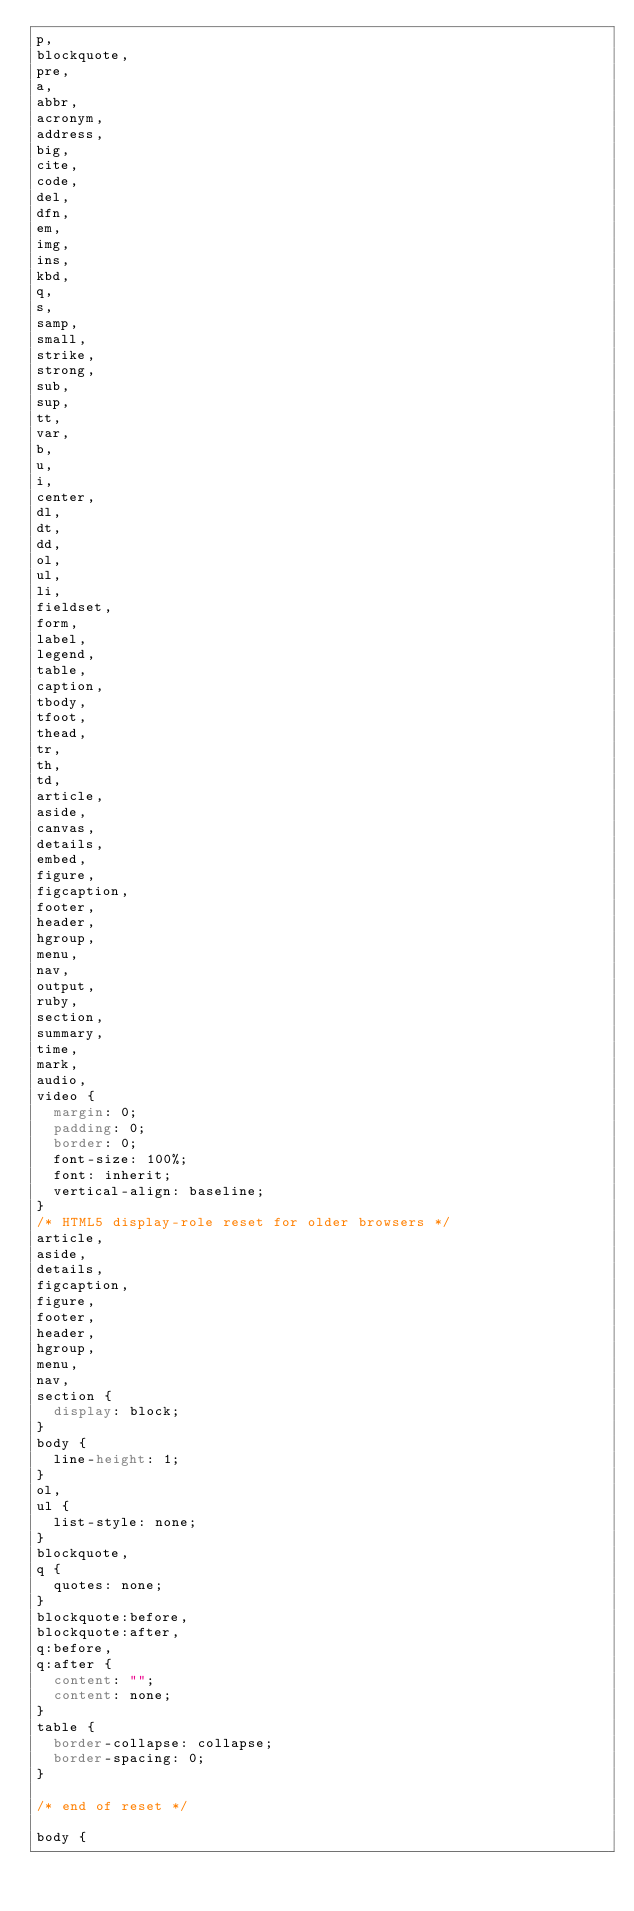Convert code to text. <code><loc_0><loc_0><loc_500><loc_500><_CSS_>p,
blockquote,
pre,
a,
abbr,
acronym,
address,
big,
cite,
code,
del,
dfn,
em,
img,
ins,
kbd,
q,
s,
samp,
small,
strike,
strong,
sub,
sup,
tt,
var,
b,
u,
i,
center,
dl,
dt,
dd,
ol,
ul,
li,
fieldset,
form,
label,
legend,
table,
caption,
tbody,
tfoot,
thead,
tr,
th,
td,
article,
aside,
canvas,
details,
embed,
figure,
figcaption,
footer,
header,
hgroup,
menu,
nav,
output,
ruby,
section,
summary,
time,
mark,
audio,
video {
  margin: 0;
  padding: 0;
  border: 0;
  font-size: 100%;
  font: inherit;
  vertical-align: baseline;
}
/* HTML5 display-role reset for older browsers */
article,
aside,
details,
figcaption,
figure,
footer,
header,
hgroup,
menu,
nav,
section {
  display: block;
}
body {
  line-height: 1;
}
ol,
ul {
  list-style: none;
}
blockquote,
q {
  quotes: none;
}
blockquote:before,
blockquote:after,
q:before,
q:after {
  content: "";
  content: none;
}
table {
  border-collapse: collapse;
  border-spacing: 0;
}

/* end of reset */

body {</code> 